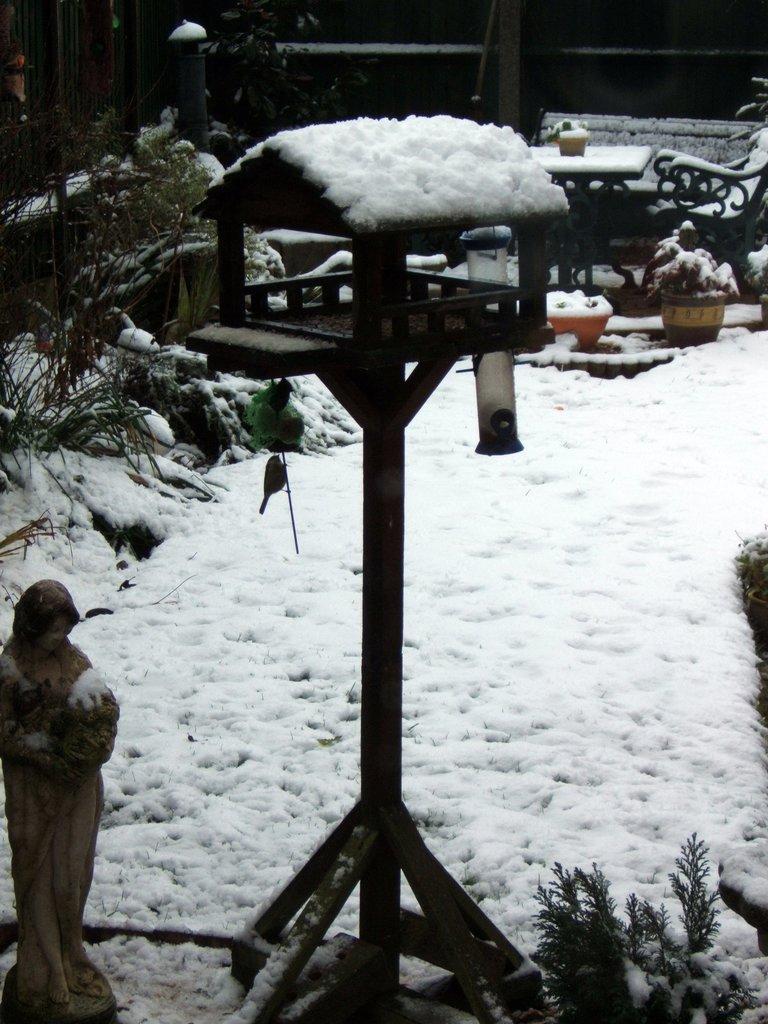Describe this image in one or two sentences. On the left side, there is a statue of a woman who is holding a baby. In the middle of this image, there is a snow on the toy house, which is on a wooden pole. On the right side, there is a plant. In the background, there is snow on the potted plants, a table, a chair and other objects. 